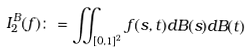Convert formula to latex. <formula><loc_0><loc_0><loc_500><loc_500>I _ { 2 } ^ { B } ( f ) \colon = \iint _ { [ 0 , 1 ] ^ { 2 } } f ( s , t ) d B ( s ) d B ( t )</formula> 